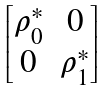<formula> <loc_0><loc_0><loc_500><loc_500>\begin{bmatrix} \rho _ { 0 } ^ { * } & 0 \\ 0 & \rho _ { 1 } ^ { * } \end{bmatrix}</formula> 